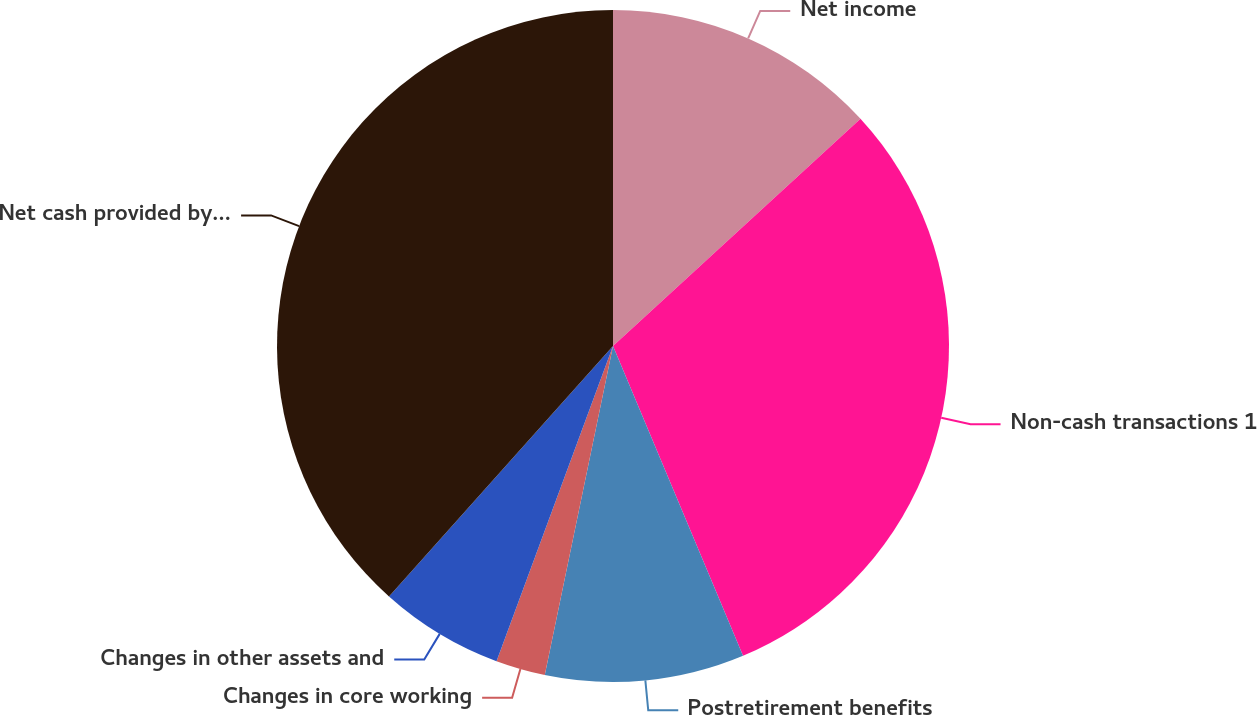Convert chart to OTSL. <chart><loc_0><loc_0><loc_500><loc_500><pie_chart><fcel>Net income<fcel>Non-cash transactions 1<fcel>Postretirement benefits<fcel>Changes in core working<fcel>Changes in other assets and<fcel>Net cash provided by operating<nl><fcel>13.18%<fcel>30.5%<fcel>9.58%<fcel>2.38%<fcel>5.98%<fcel>38.39%<nl></chart> 